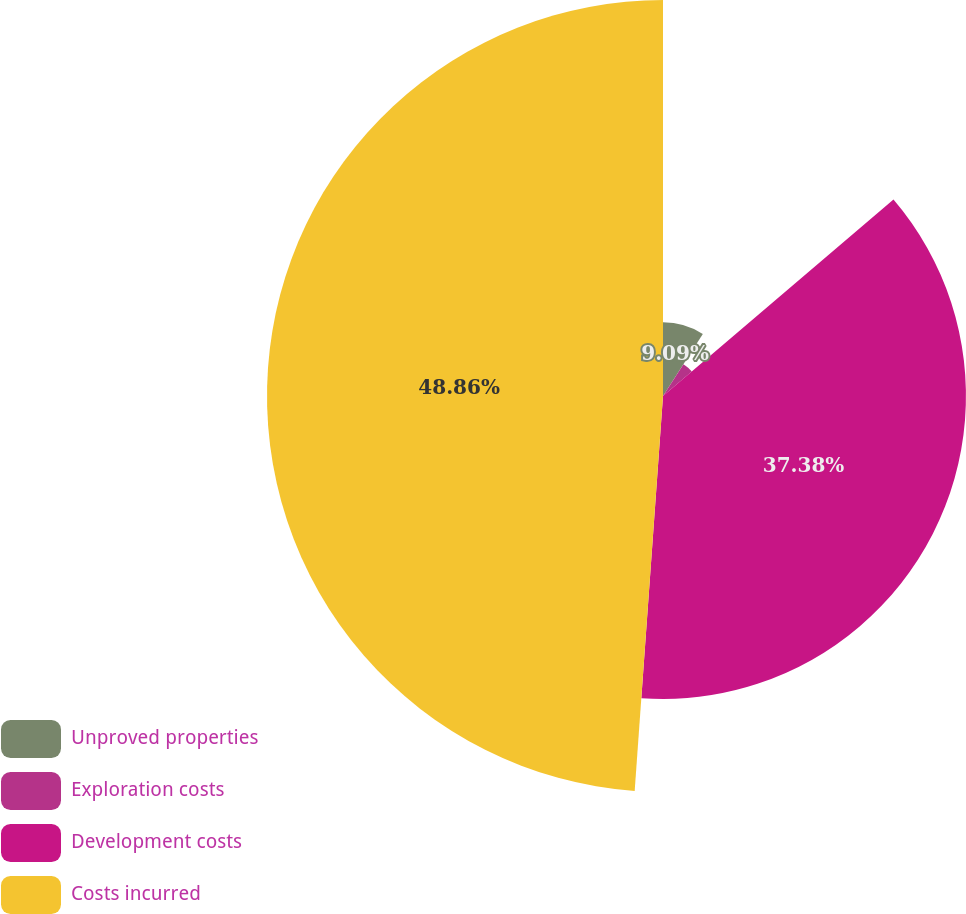Convert chart to OTSL. <chart><loc_0><loc_0><loc_500><loc_500><pie_chart><fcel>Unproved properties<fcel>Exploration costs<fcel>Development costs<fcel>Costs incurred<nl><fcel>9.09%<fcel>4.67%<fcel>37.38%<fcel>48.86%<nl></chart> 